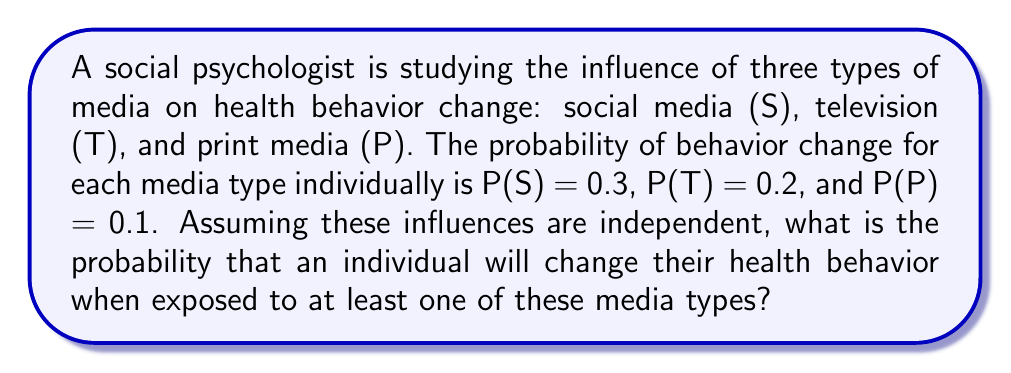Can you solve this math problem? To solve this problem, we'll use the concept of probability of the union of events. We want to find P(S ∪ T ∪ P), which is the probability of at least one of the events occurring.

Step 1: Use the complement rule.
The probability of at least one event occurring is equal to 1 minus the probability that none of the events occur.

P(S ∪ T ∪ P) = 1 - P(not S and not T and not P)

Step 2: Since the events are independent, we can multiply the probabilities of each event not occurring.

P(not S and not T and not P) = P(not S) × P(not T) × P(not P)

Step 3: Calculate the probability of each event not occurring.
P(not S) = 1 - P(S) = 1 - 0.3 = 0.7
P(not T) = 1 - P(T) = 1 - 0.2 = 0.8
P(not P) = 1 - P(P) = 1 - 0.1 = 0.9

Step 4: Multiply these probabilities.
P(not S and not T and not P) = 0.7 × 0.8 × 0.9 = 0.504

Step 5: Subtract this result from 1 to get the final answer.
P(S ∪ T ∪ P) = 1 - 0.504 = 0.496

Therefore, the probability that an individual will change their health behavior when exposed to at least one of these media types is 0.496 or 49.6%.
Answer: 0.496 